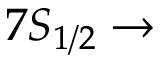Convert formula to latex. <formula><loc_0><loc_0><loc_500><loc_500>7 S _ { 1 / 2 } \rightarrow</formula> 